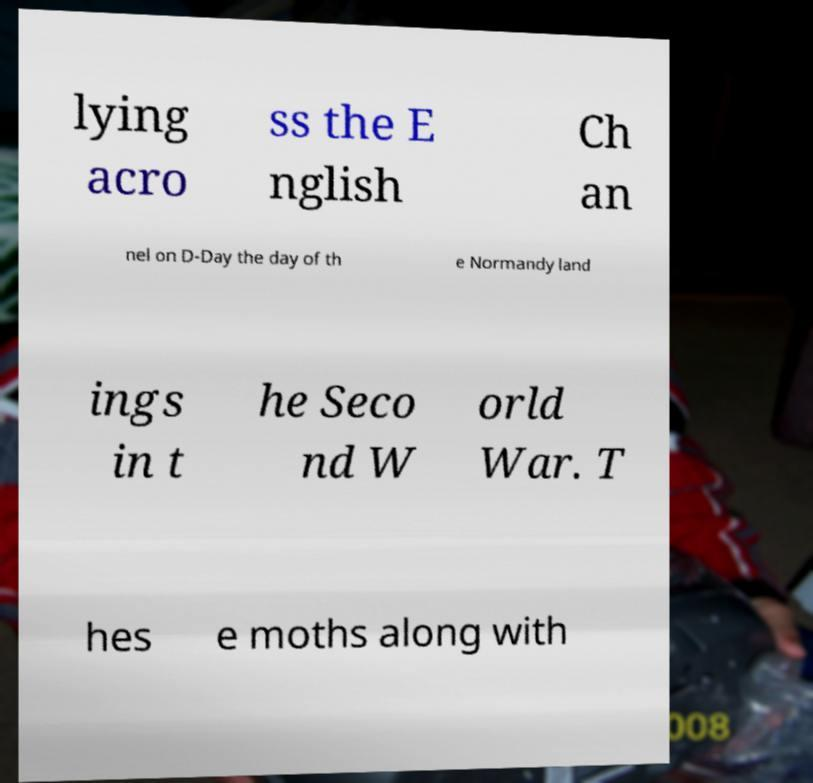Could you assist in decoding the text presented in this image and type it out clearly? lying acro ss the E nglish Ch an nel on D-Day the day of th e Normandy land ings in t he Seco nd W orld War. T hes e moths along with 